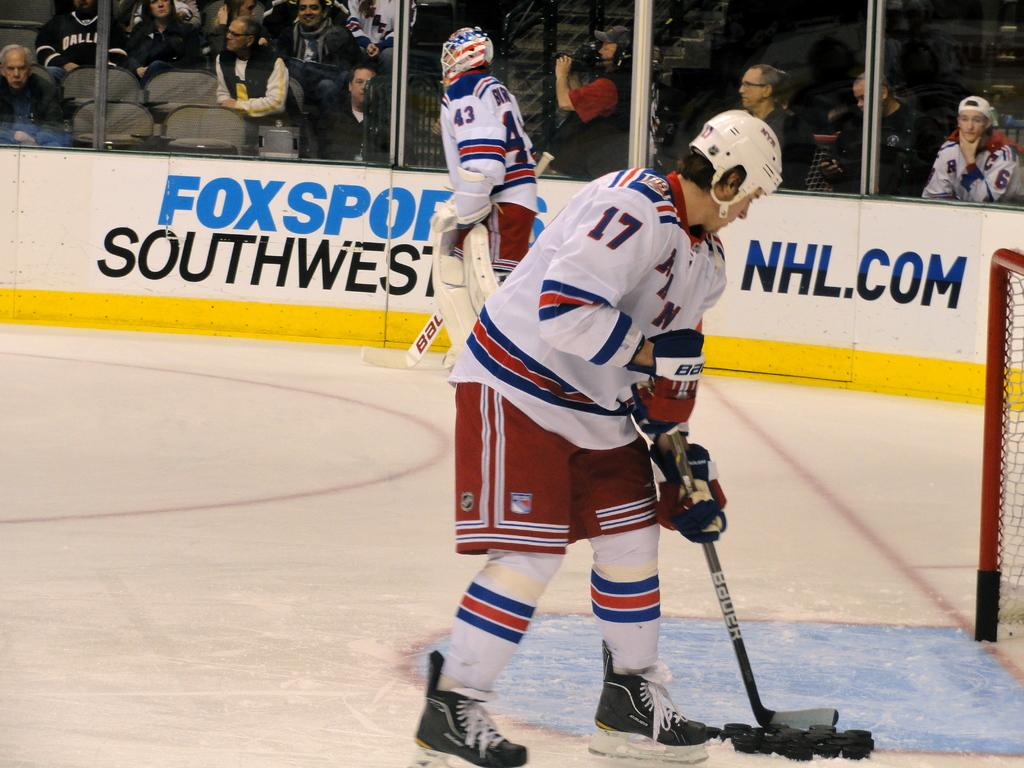<image>
Offer a succinct explanation of the picture presented. The goalie in the background is number 43 